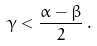<formula> <loc_0><loc_0><loc_500><loc_500>\gamma < \frac { \alpha - \beta } { 2 } \, .</formula> 